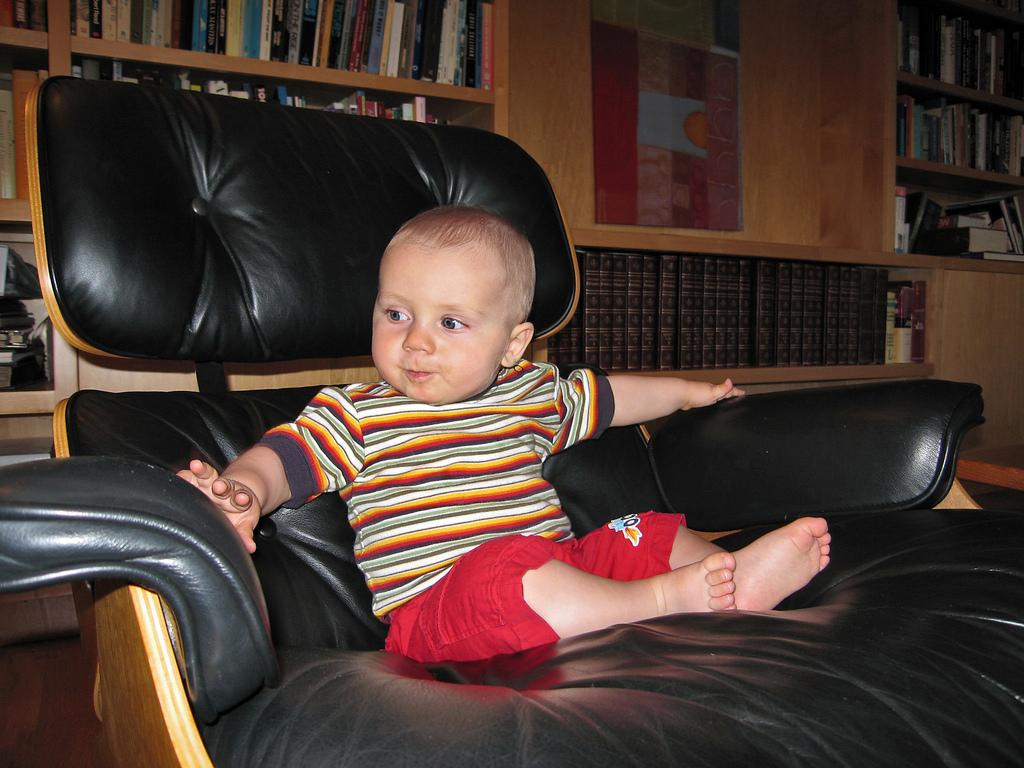What type of furniture is in the image? There is a black sofa chair in the image. Who or what is sitting on the chair? A baby is sitting on the chair. What can be seen in the background of the image? There are books in the background of the image. How are the books arranged in the image? The books are on a wooden shelf. What type of music is the baby playing on the chair? There is no music or instrument present in the image, so it cannot be determined what type of music the baby might be playing. 